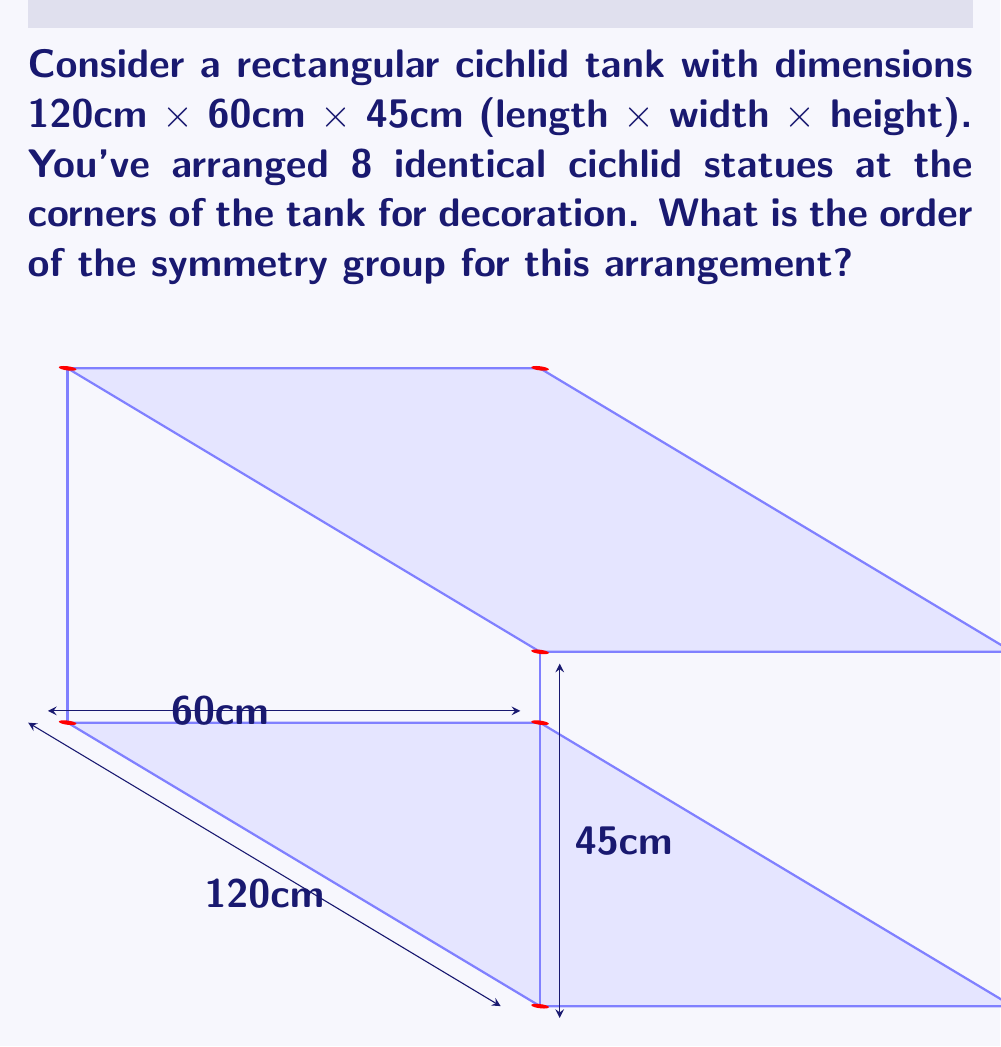Can you answer this question? Let's approach this step-by-step:

1) First, we need to identify the symmetries of this arrangement. The symmetries are the ways we can rotate or reflect the tank that leave the arrangement of statues unchanged.

2) Rotational symmetries:
   - 180° rotation around the x-axis (length)
   - 180° rotation around the y-axis (width)
   - 180° rotation around the z-axis (height)

3) Reflection symmetries:
   - Reflection across the xy-plane (middle height)
   - Reflection across the xz-plane (middle width)
   - Reflection across the yz-plane (middle length)

4) We also have the identity transformation (do nothing).

5) These symmetries form a group. Let's count them:
   - 1 identity transformation
   - 3 rotations of 180°
   - 3 reflections

6) In total, we have 1 + 3 + 3 = 7 symmetries.

7) This group is isomorphic to the dihedral group $D_4$, which is the symmetry group of a rectangle.

8) The order of a group is the number of elements in the group. Therefore, the order of this symmetry group is 7.
Answer: 7 